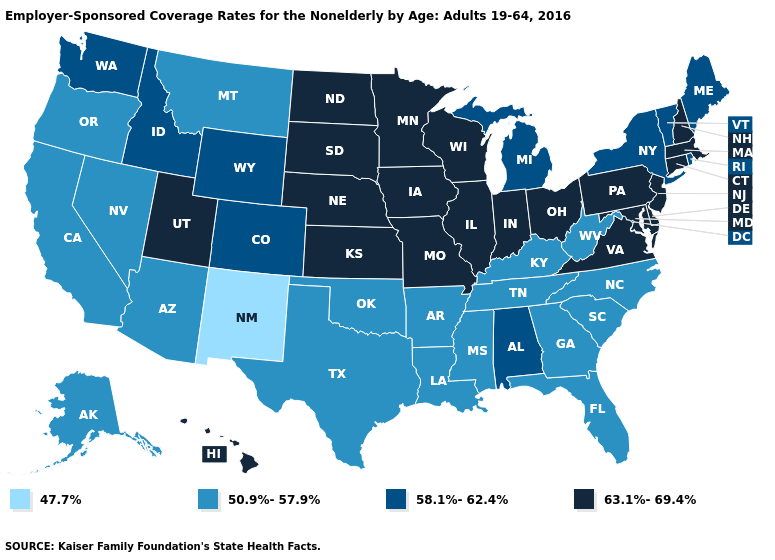What is the value of Tennessee?
Answer briefly. 50.9%-57.9%. Does Connecticut have the lowest value in the Northeast?
Be succinct. No. What is the value of Vermont?
Concise answer only. 58.1%-62.4%. What is the highest value in the USA?
Short answer required. 63.1%-69.4%. Name the states that have a value in the range 63.1%-69.4%?
Keep it brief. Connecticut, Delaware, Hawaii, Illinois, Indiana, Iowa, Kansas, Maryland, Massachusetts, Minnesota, Missouri, Nebraska, New Hampshire, New Jersey, North Dakota, Ohio, Pennsylvania, South Dakota, Utah, Virginia, Wisconsin. Name the states that have a value in the range 58.1%-62.4%?
Be succinct. Alabama, Colorado, Idaho, Maine, Michigan, New York, Rhode Island, Vermont, Washington, Wyoming. Which states have the lowest value in the USA?
Short answer required. New Mexico. Name the states that have a value in the range 63.1%-69.4%?
Keep it brief. Connecticut, Delaware, Hawaii, Illinois, Indiana, Iowa, Kansas, Maryland, Massachusetts, Minnesota, Missouri, Nebraska, New Hampshire, New Jersey, North Dakota, Ohio, Pennsylvania, South Dakota, Utah, Virginia, Wisconsin. Which states have the lowest value in the USA?
Answer briefly. New Mexico. Does New Mexico have the lowest value in the West?
Answer briefly. Yes. Among the states that border Idaho , does Nevada have the highest value?
Give a very brief answer. No. Name the states that have a value in the range 50.9%-57.9%?
Write a very short answer. Alaska, Arizona, Arkansas, California, Florida, Georgia, Kentucky, Louisiana, Mississippi, Montana, Nevada, North Carolina, Oklahoma, Oregon, South Carolina, Tennessee, Texas, West Virginia. Name the states that have a value in the range 50.9%-57.9%?
Answer briefly. Alaska, Arizona, Arkansas, California, Florida, Georgia, Kentucky, Louisiana, Mississippi, Montana, Nevada, North Carolina, Oklahoma, Oregon, South Carolina, Tennessee, Texas, West Virginia. What is the lowest value in the USA?
Short answer required. 47.7%. Does Rhode Island have a higher value than Nebraska?
Write a very short answer. No. 